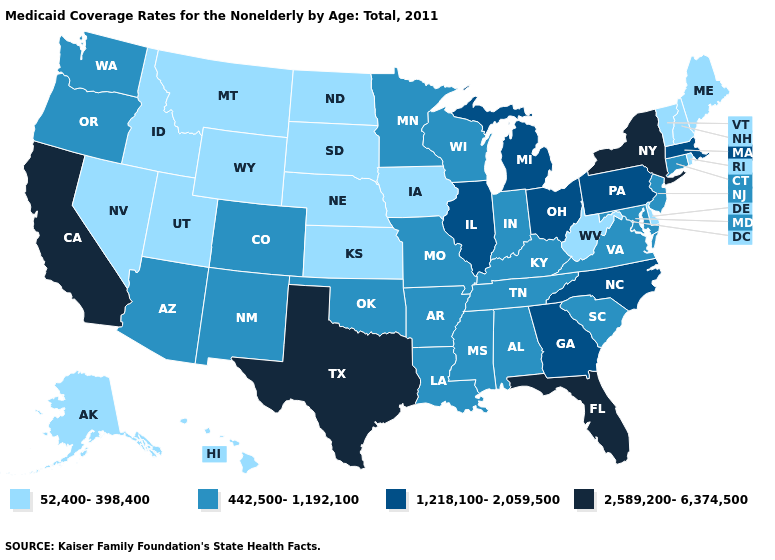Does West Virginia have the lowest value in the South?
Give a very brief answer. Yes. Name the states that have a value in the range 52,400-398,400?
Keep it brief. Alaska, Delaware, Hawaii, Idaho, Iowa, Kansas, Maine, Montana, Nebraska, Nevada, New Hampshire, North Dakota, Rhode Island, South Dakota, Utah, Vermont, West Virginia, Wyoming. Does the first symbol in the legend represent the smallest category?
Give a very brief answer. Yes. Name the states that have a value in the range 442,500-1,192,100?
Keep it brief. Alabama, Arizona, Arkansas, Colorado, Connecticut, Indiana, Kentucky, Louisiana, Maryland, Minnesota, Mississippi, Missouri, New Jersey, New Mexico, Oklahoma, Oregon, South Carolina, Tennessee, Virginia, Washington, Wisconsin. What is the value of Oklahoma?
Write a very short answer. 442,500-1,192,100. What is the value of Tennessee?
Keep it brief. 442,500-1,192,100. Name the states that have a value in the range 442,500-1,192,100?
Be succinct. Alabama, Arizona, Arkansas, Colorado, Connecticut, Indiana, Kentucky, Louisiana, Maryland, Minnesota, Mississippi, Missouri, New Jersey, New Mexico, Oklahoma, Oregon, South Carolina, Tennessee, Virginia, Washington, Wisconsin. What is the highest value in the Northeast ?
Write a very short answer. 2,589,200-6,374,500. Which states have the lowest value in the USA?
Answer briefly. Alaska, Delaware, Hawaii, Idaho, Iowa, Kansas, Maine, Montana, Nebraska, Nevada, New Hampshire, North Dakota, Rhode Island, South Dakota, Utah, Vermont, West Virginia, Wyoming. Name the states that have a value in the range 442,500-1,192,100?
Give a very brief answer. Alabama, Arizona, Arkansas, Colorado, Connecticut, Indiana, Kentucky, Louisiana, Maryland, Minnesota, Mississippi, Missouri, New Jersey, New Mexico, Oklahoma, Oregon, South Carolina, Tennessee, Virginia, Washington, Wisconsin. Which states have the lowest value in the USA?
Short answer required. Alaska, Delaware, Hawaii, Idaho, Iowa, Kansas, Maine, Montana, Nebraska, Nevada, New Hampshire, North Dakota, Rhode Island, South Dakota, Utah, Vermont, West Virginia, Wyoming. Name the states that have a value in the range 442,500-1,192,100?
Give a very brief answer. Alabama, Arizona, Arkansas, Colorado, Connecticut, Indiana, Kentucky, Louisiana, Maryland, Minnesota, Mississippi, Missouri, New Jersey, New Mexico, Oklahoma, Oregon, South Carolina, Tennessee, Virginia, Washington, Wisconsin. Which states have the lowest value in the USA?
Quick response, please. Alaska, Delaware, Hawaii, Idaho, Iowa, Kansas, Maine, Montana, Nebraska, Nevada, New Hampshire, North Dakota, Rhode Island, South Dakota, Utah, Vermont, West Virginia, Wyoming. Does the map have missing data?
Concise answer only. No. Name the states that have a value in the range 52,400-398,400?
Quick response, please. Alaska, Delaware, Hawaii, Idaho, Iowa, Kansas, Maine, Montana, Nebraska, Nevada, New Hampshire, North Dakota, Rhode Island, South Dakota, Utah, Vermont, West Virginia, Wyoming. 